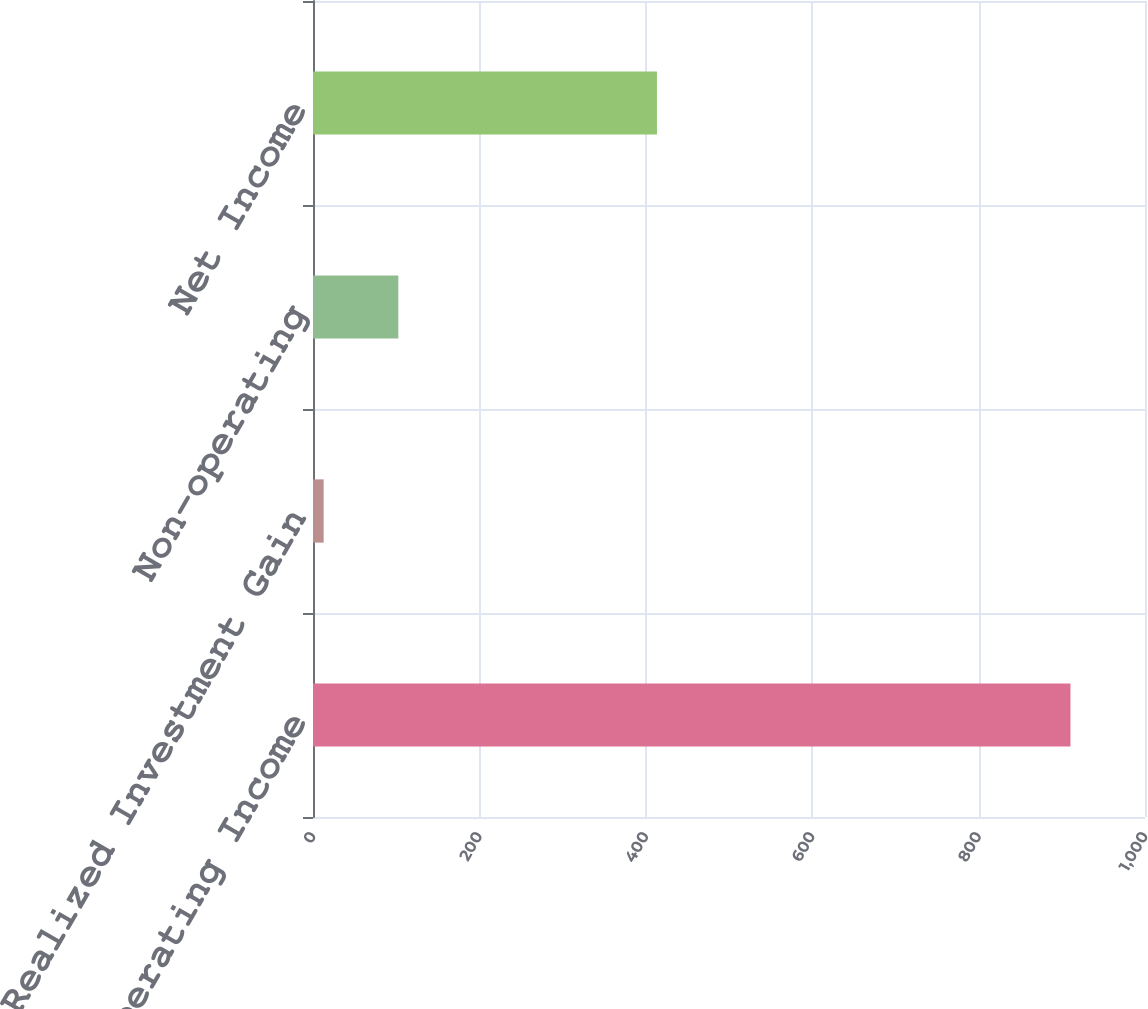<chart> <loc_0><loc_0><loc_500><loc_500><bar_chart><fcel>After-tax Operating Income<fcel>Net Realized Investment Gain<fcel>Non-operating<fcel>Net Income<nl><fcel>910.4<fcel>12.8<fcel>102.56<fcel>413.4<nl></chart> 